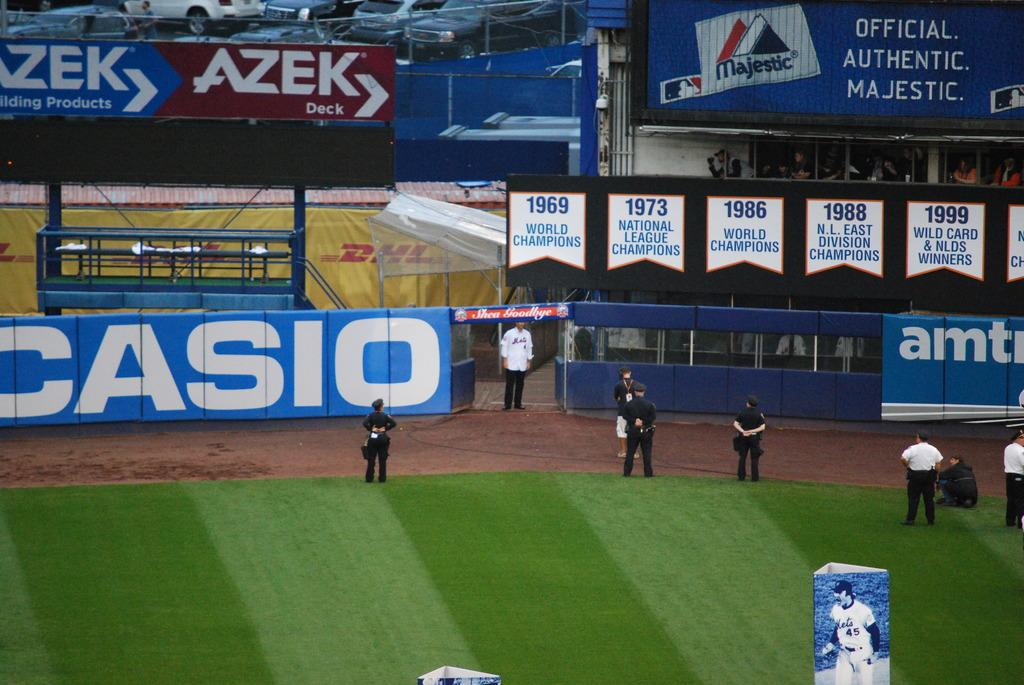Provide a one-sentence caption for the provided image. Baseball stadium with an ad for CASIO on the side. 